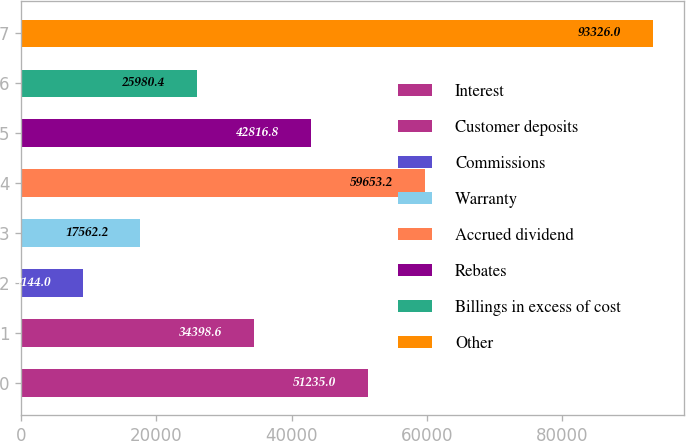Convert chart. <chart><loc_0><loc_0><loc_500><loc_500><bar_chart><fcel>Interest<fcel>Customer deposits<fcel>Commissions<fcel>Warranty<fcel>Accrued dividend<fcel>Rebates<fcel>Billings in excess of cost<fcel>Other<nl><fcel>51235<fcel>34398.6<fcel>9144<fcel>17562.2<fcel>59653.2<fcel>42816.8<fcel>25980.4<fcel>93326<nl></chart> 